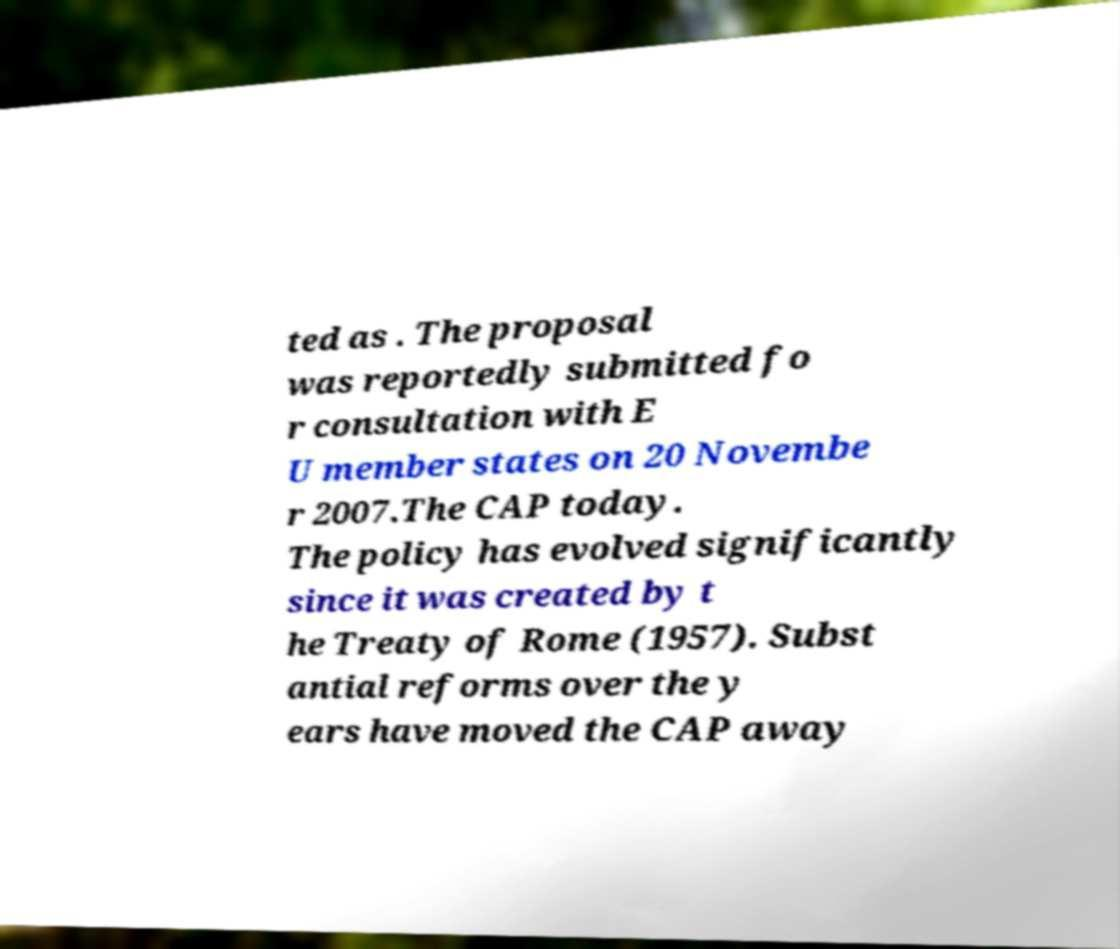Could you extract and type out the text from this image? ted as . The proposal was reportedly submitted fo r consultation with E U member states on 20 Novembe r 2007.The CAP today. The policy has evolved significantly since it was created by t he Treaty of Rome (1957). Subst antial reforms over the y ears have moved the CAP away 